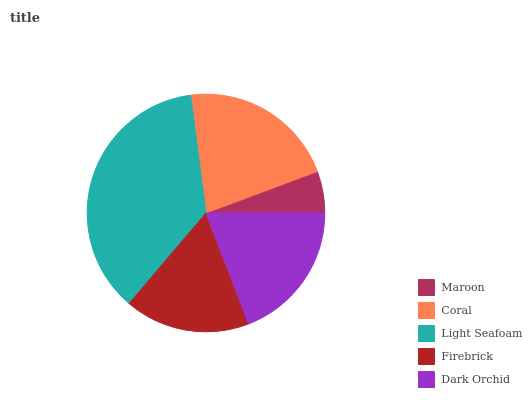Is Maroon the minimum?
Answer yes or no. Yes. Is Light Seafoam the maximum?
Answer yes or no. Yes. Is Coral the minimum?
Answer yes or no. No. Is Coral the maximum?
Answer yes or no. No. Is Coral greater than Maroon?
Answer yes or no. Yes. Is Maroon less than Coral?
Answer yes or no. Yes. Is Maroon greater than Coral?
Answer yes or no. No. Is Coral less than Maroon?
Answer yes or no. No. Is Dark Orchid the high median?
Answer yes or no. Yes. Is Dark Orchid the low median?
Answer yes or no. Yes. Is Coral the high median?
Answer yes or no. No. Is Firebrick the low median?
Answer yes or no. No. 